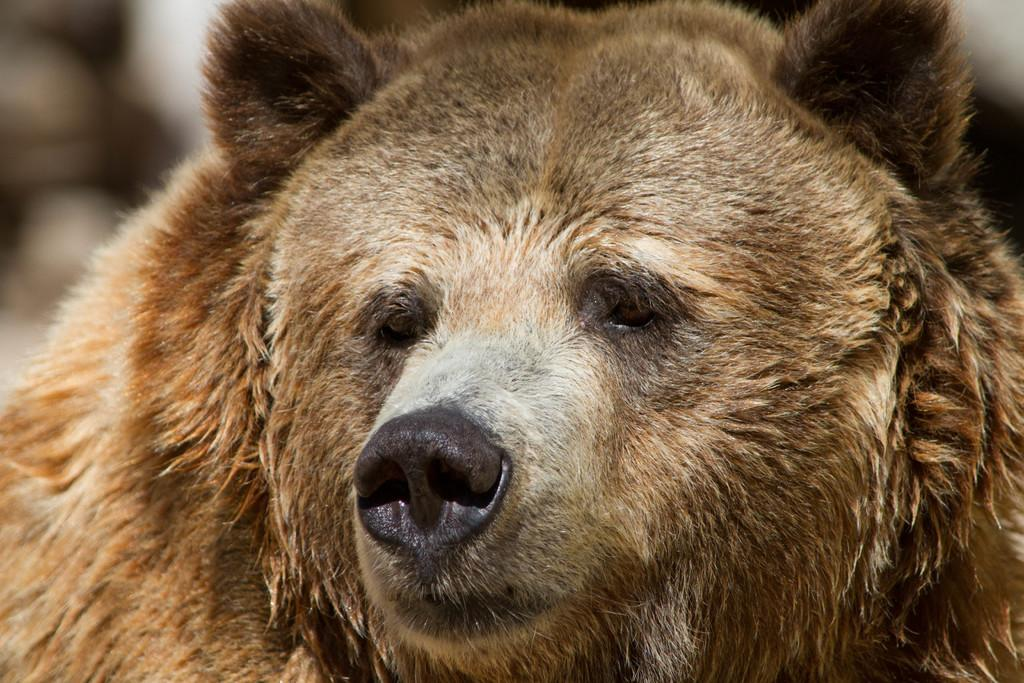What type of living creature is present in the image? There is an animal in the image. What type of plate is being used by the cent in the image? There is no cent or plate present in the image; it only features an animal. 